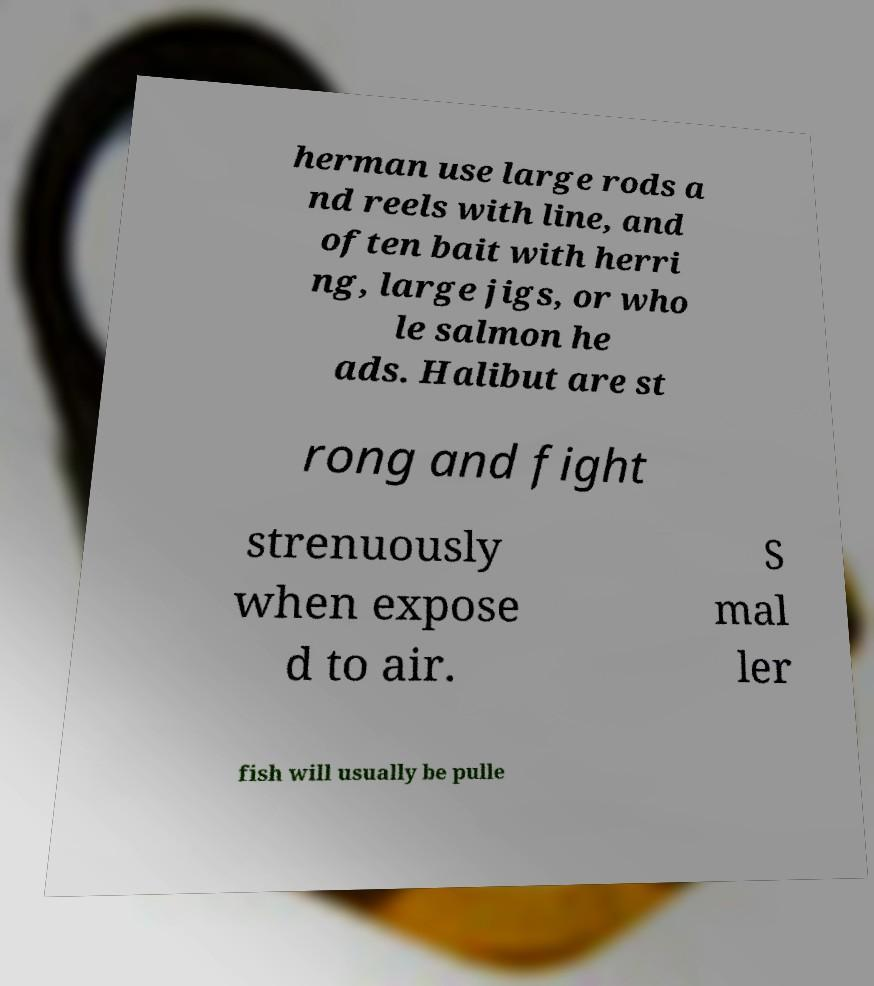What messages or text are displayed in this image? I need them in a readable, typed format. herman use large rods a nd reels with line, and often bait with herri ng, large jigs, or who le salmon he ads. Halibut are st rong and fight strenuously when expose d to air. S mal ler fish will usually be pulle 